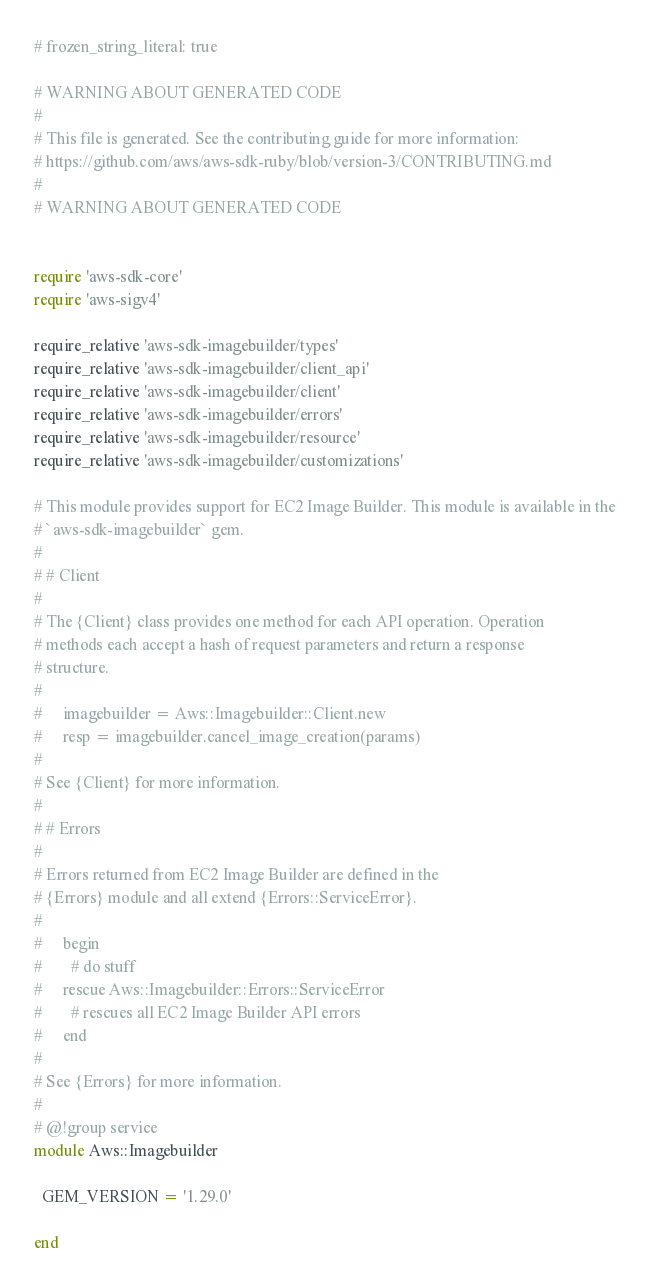Convert code to text. <code><loc_0><loc_0><loc_500><loc_500><_Ruby_># frozen_string_literal: true

# WARNING ABOUT GENERATED CODE
#
# This file is generated. See the contributing guide for more information:
# https://github.com/aws/aws-sdk-ruby/blob/version-3/CONTRIBUTING.md
#
# WARNING ABOUT GENERATED CODE


require 'aws-sdk-core'
require 'aws-sigv4'

require_relative 'aws-sdk-imagebuilder/types'
require_relative 'aws-sdk-imagebuilder/client_api'
require_relative 'aws-sdk-imagebuilder/client'
require_relative 'aws-sdk-imagebuilder/errors'
require_relative 'aws-sdk-imagebuilder/resource'
require_relative 'aws-sdk-imagebuilder/customizations'

# This module provides support for EC2 Image Builder. This module is available in the
# `aws-sdk-imagebuilder` gem.
#
# # Client
#
# The {Client} class provides one method for each API operation. Operation
# methods each accept a hash of request parameters and return a response
# structure.
#
#     imagebuilder = Aws::Imagebuilder::Client.new
#     resp = imagebuilder.cancel_image_creation(params)
#
# See {Client} for more information.
#
# # Errors
#
# Errors returned from EC2 Image Builder are defined in the
# {Errors} module and all extend {Errors::ServiceError}.
#
#     begin
#       # do stuff
#     rescue Aws::Imagebuilder::Errors::ServiceError
#       # rescues all EC2 Image Builder API errors
#     end
#
# See {Errors} for more information.
#
# @!group service
module Aws::Imagebuilder

  GEM_VERSION = '1.29.0'

end
</code> 